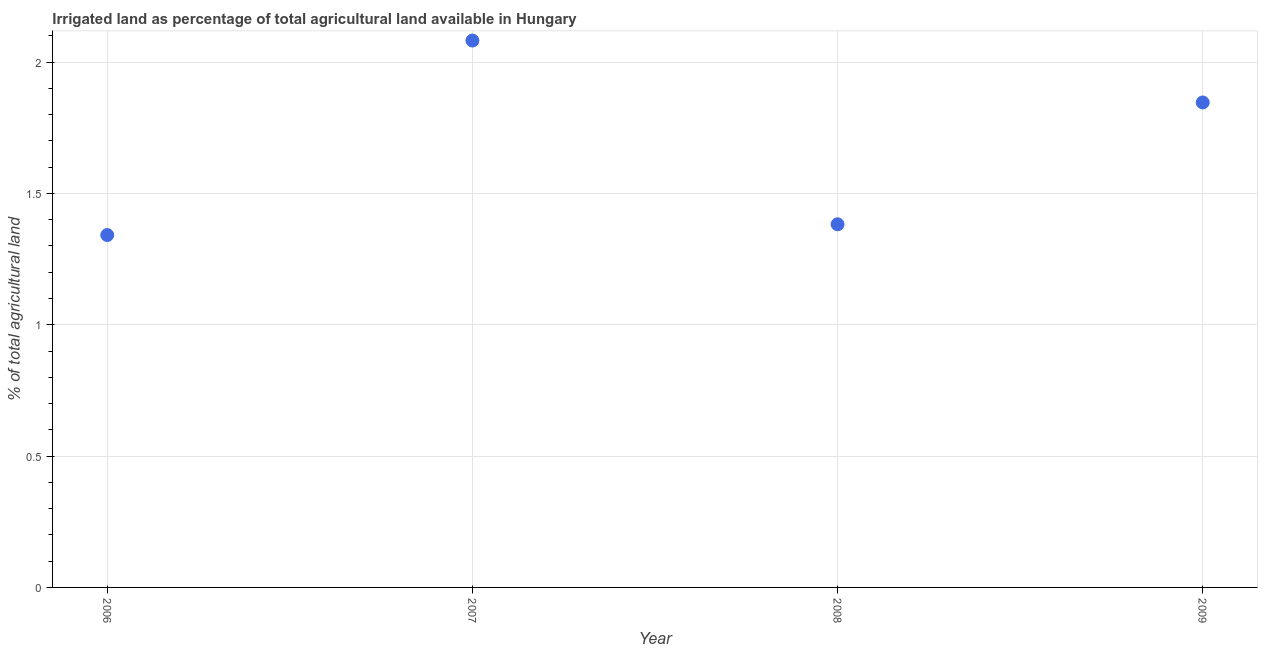What is the percentage of agricultural irrigated land in 2007?
Ensure brevity in your answer.  2.08. Across all years, what is the maximum percentage of agricultural irrigated land?
Ensure brevity in your answer.  2.08. Across all years, what is the minimum percentage of agricultural irrigated land?
Offer a terse response. 1.34. In which year was the percentage of agricultural irrigated land maximum?
Your response must be concise. 2007. In which year was the percentage of agricultural irrigated land minimum?
Your answer should be compact. 2006. What is the sum of the percentage of agricultural irrigated land?
Your answer should be compact. 6.65. What is the difference between the percentage of agricultural irrigated land in 2006 and 2007?
Keep it short and to the point. -0.74. What is the average percentage of agricultural irrigated land per year?
Make the answer very short. 1.66. What is the median percentage of agricultural irrigated land?
Provide a short and direct response. 1.61. In how many years, is the percentage of agricultural irrigated land greater than 0.5 %?
Your response must be concise. 4. What is the ratio of the percentage of agricultural irrigated land in 2007 to that in 2009?
Provide a succinct answer. 1.13. Is the difference between the percentage of agricultural irrigated land in 2006 and 2008 greater than the difference between any two years?
Your answer should be compact. No. What is the difference between the highest and the second highest percentage of agricultural irrigated land?
Provide a short and direct response. 0.24. Is the sum of the percentage of agricultural irrigated land in 2007 and 2008 greater than the maximum percentage of agricultural irrigated land across all years?
Your answer should be very brief. Yes. What is the difference between the highest and the lowest percentage of agricultural irrigated land?
Provide a succinct answer. 0.74. How many dotlines are there?
Provide a short and direct response. 1. What is the difference between two consecutive major ticks on the Y-axis?
Offer a very short reply. 0.5. What is the title of the graph?
Keep it short and to the point. Irrigated land as percentage of total agricultural land available in Hungary. What is the label or title of the Y-axis?
Provide a succinct answer. % of total agricultural land. What is the % of total agricultural land in 2006?
Offer a very short reply. 1.34. What is the % of total agricultural land in 2007?
Provide a short and direct response. 2.08. What is the % of total agricultural land in 2008?
Make the answer very short. 1.38. What is the % of total agricultural land in 2009?
Give a very brief answer. 1.85. What is the difference between the % of total agricultural land in 2006 and 2007?
Your answer should be very brief. -0.74. What is the difference between the % of total agricultural land in 2006 and 2008?
Offer a terse response. -0.04. What is the difference between the % of total agricultural land in 2006 and 2009?
Ensure brevity in your answer.  -0.5. What is the difference between the % of total agricultural land in 2007 and 2008?
Provide a short and direct response. 0.7. What is the difference between the % of total agricultural land in 2007 and 2009?
Your answer should be very brief. 0.24. What is the difference between the % of total agricultural land in 2008 and 2009?
Provide a short and direct response. -0.46. What is the ratio of the % of total agricultural land in 2006 to that in 2007?
Your answer should be very brief. 0.64. What is the ratio of the % of total agricultural land in 2006 to that in 2009?
Offer a terse response. 0.73. What is the ratio of the % of total agricultural land in 2007 to that in 2008?
Give a very brief answer. 1.51. What is the ratio of the % of total agricultural land in 2007 to that in 2009?
Your answer should be very brief. 1.13. What is the ratio of the % of total agricultural land in 2008 to that in 2009?
Your answer should be compact. 0.75. 